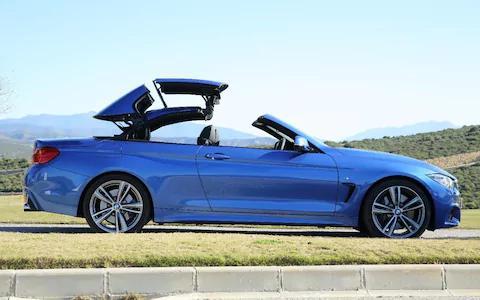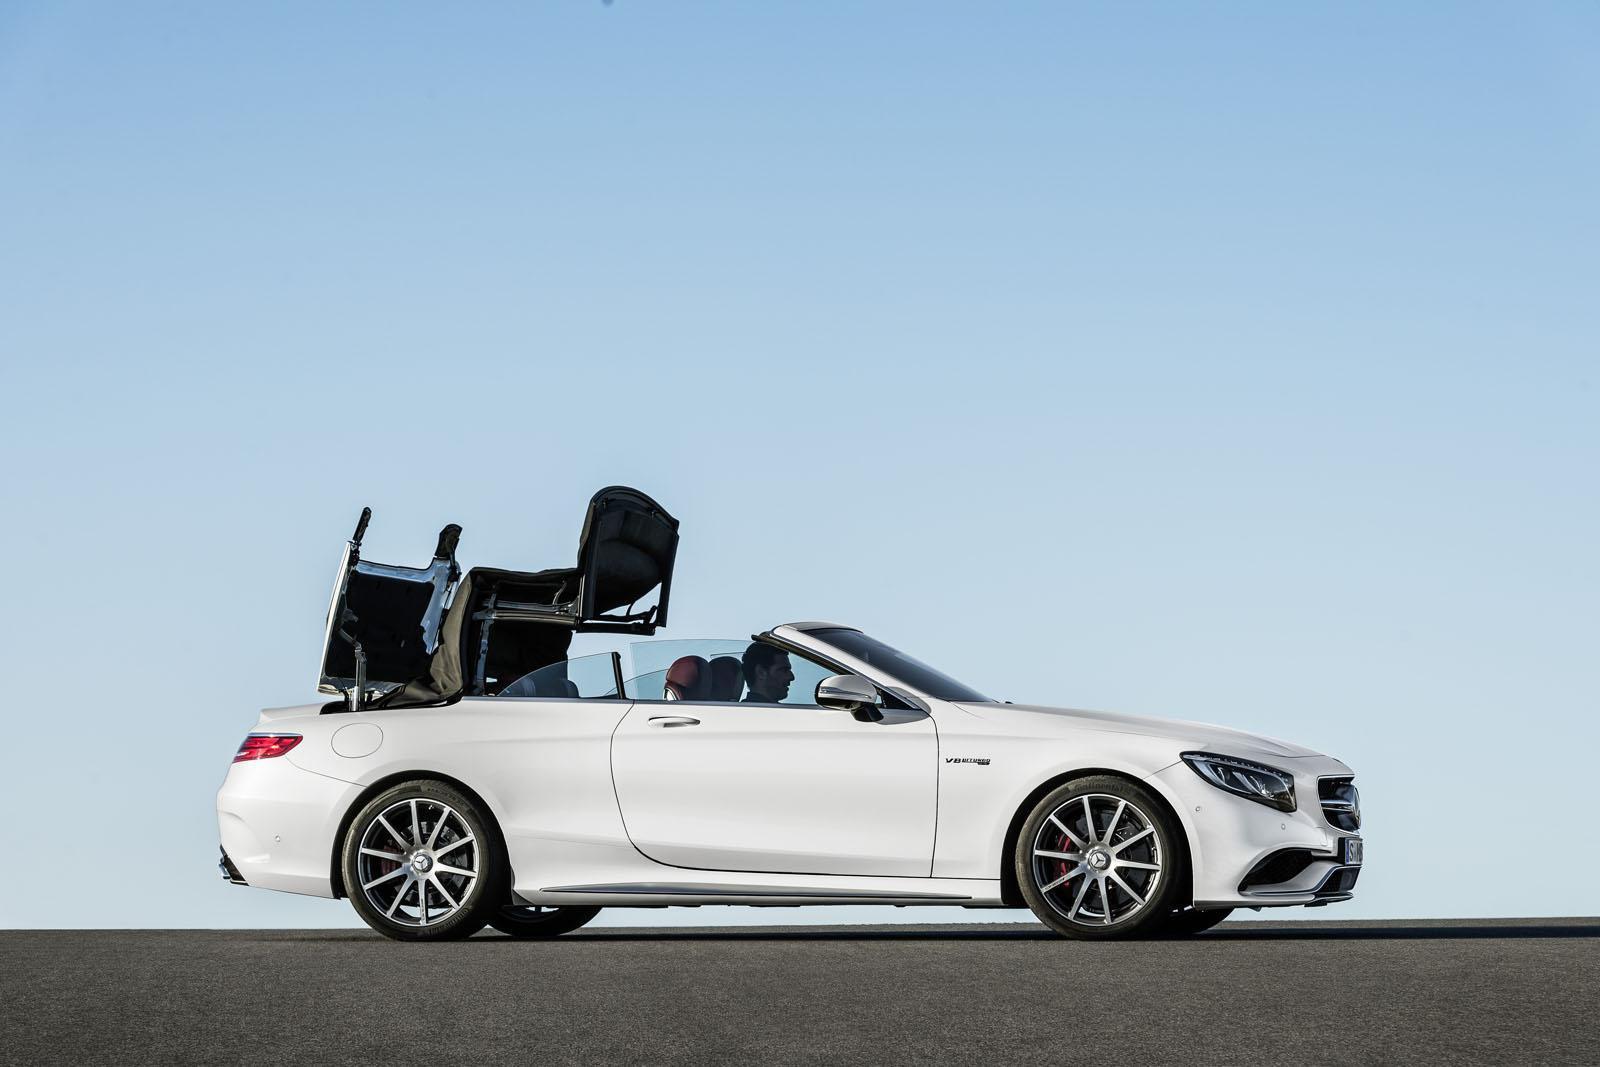The first image is the image on the left, the second image is the image on the right. For the images shown, is this caption "An image shows brown rocky peaks behind a white convertible with its top partly extended." true? Answer yes or no. No. The first image is the image on the left, the second image is the image on the right. Examine the images to the left and right. Is the description "Each image shows the entire length of a sports car with a convertible top that is in the act of being lowered." accurate? Answer yes or no. Yes. 